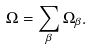Convert formula to latex. <formula><loc_0><loc_0><loc_500><loc_500>\Omega = \sum _ { \beta } \Omega _ { \beta } .</formula> 